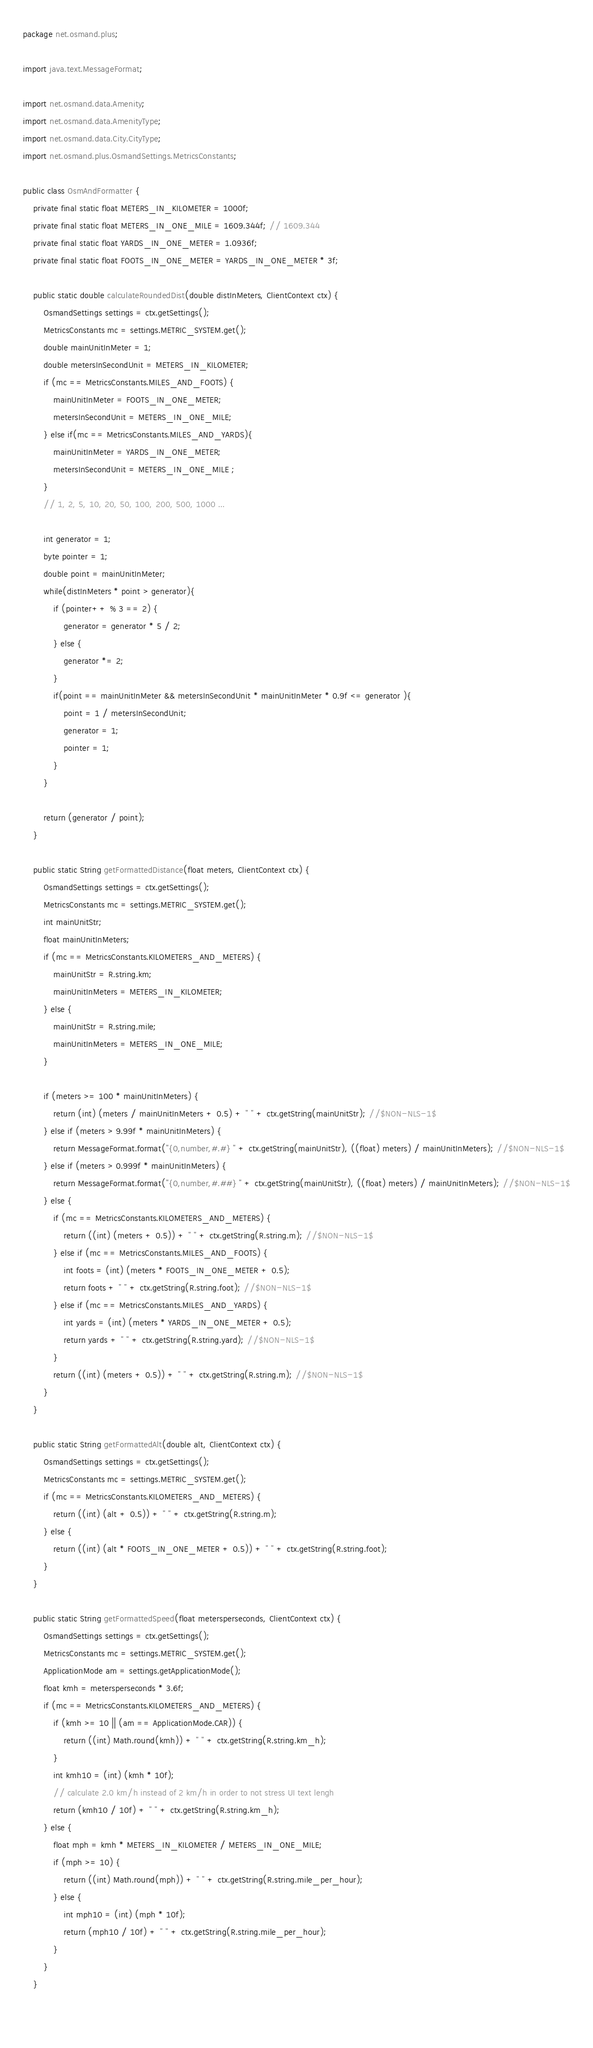<code> <loc_0><loc_0><loc_500><loc_500><_Java_>package net.osmand.plus;

import java.text.MessageFormat;

import net.osmand.data.Amenity;
import net.osmand.data.AmenityType;
import net.osmand.data.City.CityType;
import net.osmand.plus.OsmandSettings.MetricsConstants;

public class OsmAndFormatter {
	private final static float METERS_IN_KILOMETER = 1000f;
	private final static float METERS_IN_ONE_MILE = 1609.344f; // 1609.344
	private final static float YARDS_IN_ONE_METER = 1.0936f;
	private final static float FOOTS_IN_ONE_METER = YARDS_IN_ONE_METER * 3f;
	
	public static double calculateRoundedDist(double distInMeters, ClientContext ctx) {
		OsmandSettings settings = ctx.getSettings();
		MetricsConstants mc = settings.METRIC_SYSTEM.get();
		double mainUnitInMeter = 1;
		double metersInSecondUnit = METERS_IN_KILOMETER; 
		if (mc == MetricsConstants.MILES_AND_FOOTS) {
			mainUnitInMeter = FOOTS_IN_ONE_METER;
			metersInSecondUnit = METERS_IN_ONE_MILE;
		} else if(mc == MetricsConstants.MILES_AND_YARDS){
			mainUnitInMeter = YARDS_IN_ONE_METER;
			metersInSecondUnit = METERS_IN_ONE_MILE ;
		}
		// 1, 2, 5, 10, 20, 50, 100, 200, 500, 1000 ...
		
		int generator = 1;
		byte pointer = 1;
		double point = mainUnitInMeter;
		while(distInMeters * point > generator){
			if (pointer++ % 3 == 2) {
				generator = generator * 5 / 2;
			} else {
				generator *= 2;
			}
			if(point == mainUnitInMeter && metersInSecondUnit * mainUnitInMeter * 0.9f <= generator ){
				point = 1 / metersInSecondUnit;
				generator = 1;
				pointer = 1;
			}
		}
		
		return (generator / point);
	}
	
	public static String getFormattedDistance(float meters, ClientContext ctx) {
		OsmandSettings settings = ctx.getSettings();
		MetricsConstants mc = settings.METRIC_SYSTEM.get();
		int mainUnitStr;
		float mainUnitInMeters;
		if (mc == MetricsConstants.KILOMETERS_AND_METERS) {
			mainUnitStr = R.string.km;
			mainUnitInMeters = METERS_IN_KILOMETER;
		} else {
			mainUnitStr = R.string.mile;
			mainUnitInMeters = METERS_IN_ONE_MILE;
		}

		if (meters >= 100 * mainUnitInMeters) {
			return (int) (meters / mainUnitInMeters + 0.5) + " " + ctx.getString(mainUnitStr); //$NON-NLS-1$
		} else if (meters > 9.99f * mainUnitInMeters) {
			return MessageFormat.format("{0,number,#.#} " + ctx.getString(mainUnitStr), ((float) meters) / mainUnitInMeters); //$NON-NLS-1$
		} else if (meters > 0.999f * mainUnitInMeters) {
			return MessageFormat.format("{0,number,#.##} " + ctx.getString(mainUnitStr), ((float) meters) / mainUnitInMeters); //$NON-NLS-1$
		} else {
			if (mc == MetricsConstants.KILOMETERS_AND_METERS) {
				return ((int) (meters + 0.5)) + " " + ctx.getString(R.string.m); //$NON-NLS-1$
			} else if (mc == MetricsConstants.MILES_AND_FOOTS) {
				int foots = (int) (meters * FOOTS_IN_ONE_METER + 0.5);
				return foots + " " + ctx.getString(R.string.foot); //$NON-NLS-1$
			} else if (mc == MetricsConstants.MILES_AND_YARDS) {
				int yards = (int) (meters * YARDS_IN_ONE_METER + 0.5);
				return yards + " " + ctx.getString(R.string.yard); //$NON-NLS-1$
			}
			return ((int) (meters + 0.5)) + " " + ctx.getString(R.string.m); //$NON-NLS-1$
		}
	}

	public static String getFormattedAlt(double alt, ClientContext ctx) {
		OsmandSettings settings = ctx.getSettings();
		MetricsConstants mc = settings.METRIC_SYSTEM.get();
		if (mc == MetricsConstants.KILOMETERS_AND_METERS) {
			return ((int) (alt + 0.5)) + " " + ctx.getString(R.string.m);
		} else {
			return ((int) (alt * FOOTS_IN_ONE_METER + 0.5)) + " " + ctx.getString(R.string.foot);
		}
	}
	
	public static String getFormattedSpeed(float metersperseconds, ClientContext ctx) {
		OsmandSettings settings = ctx.getSettings();
		MetricsConstants mc = settings.METRIC_SYSTEM.get();
		ApplicationMode am = settings.getApplicationMode();
		float kmh = metersperseconds * 3.6f;
		if (mc == MetricsConstants.KILOMETERS_AND_METERS) {
			if (kmh >= 10 || (am == ApplicationMode.CAR)) {
				return ((int) Math.round(kmh)) + " " + ctx.getString(R.string.km_h);
			}
			int kmh10 = (int) (kmh * 10f);
			// calculate 2.0 km/h instead of 2 km/h in order to not stress UI text lengh
			return (kmh10 / 10f) + " " + ctx.getString(R.string.km_h);
		} else {
			float mph = kmh * METERS_IN_KILOMETER / METERS_IN_ONE_MILE;
			if (mph >= 10) {
				return ((int) Math.round(mph)) + " " + ctx.getString(R.string.mile_per_hour);
			} else {
				int mph10 = (int) (mph * 10f);
				return (mph10 / 10f) + " " + ctx.getString(R.string.mile_per_hour);
			}
		}
	}
	
	</code> 